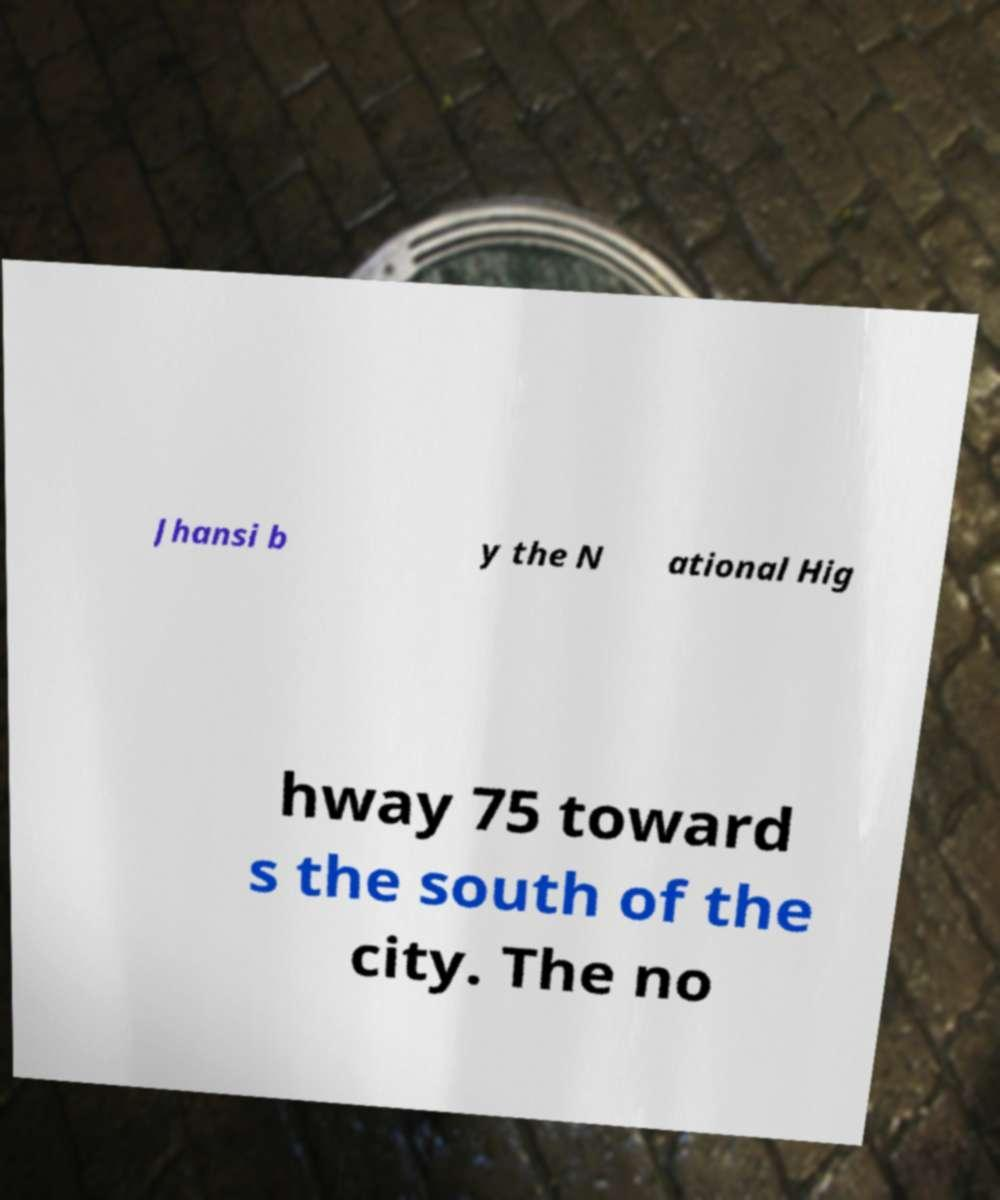For documentation purposes, I need the text within this image transcribed. Could you provide that? Jhansi b y the N ational Hig hway 75 toward s the south of the city. The no 